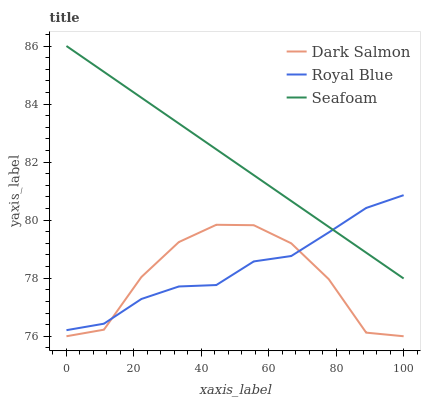Does Dark Salmon have the minimum area under the curve?
Answer yes or no. Yes. Does Seafoam have the maximum area under the curve?
Answer yes or no. Yes. Does Seafoam have the minimum area under the curve?
Answer yes or no. No. Does Dark Salmon have the maximum area under the curve?
Answer yes or no. No. Is Seafoam the smoothest?
Answer yes or no. Yes. Is Dark Salmon the roughest?
Answer yes or no. Yes. Is Dark Salmon the smoothest?
Answer yes or no. No. Is Seafoam the roughest?
Answer yes or no. No. Does Dark Salmon have the lowest value?
Answer yes or no. Yes. Does Seafoam have the lowest value?
Answer yes or no. No. Does Seafoam have the highest value?
Answer yes or no. Yes. Does Dark Salmon have the highest value?
Answer yes or no. No. Is Dark Salmon less than Seafoam?
Answer yes or no. Yes. Is Seafoam greater than Dark Salmon?
Answer yes or no. Yes. Does Seafoam intersect Royal Blue?
Answer yes or no. Yes. Is Seafoam less than Royal Blue?
Answer yes or no. No. Is Seafoam greater than Royal Blue?
Answer yes or no. No. Does Dark Salmon intersect Seafoam?
Answer yes or no. No. 